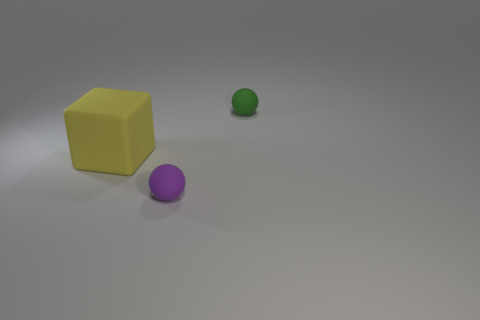Subtract all green spheres. How many spheres are left? 1 Subtract 1 balls. How many balls are left? 1 Add 1 small gray blocks. How many small gray blocks exist? 1 Add 2 large brown matte things. How many objects exist? 5 Subtract 0 blue balls. How many objects are left? 3 Subtract all spheres. How many objects are left? 1 Subtract all brown spheres. Subtract all blue cylinders. How many spheres are left? 2 Subtract all green balls. How many blue cubes are left? 0 Subtract all green metallic blocks. Subtract all big cubes. How many objects are left? 2 Add 3 big matte objects. How many big matte objects are left? 4 